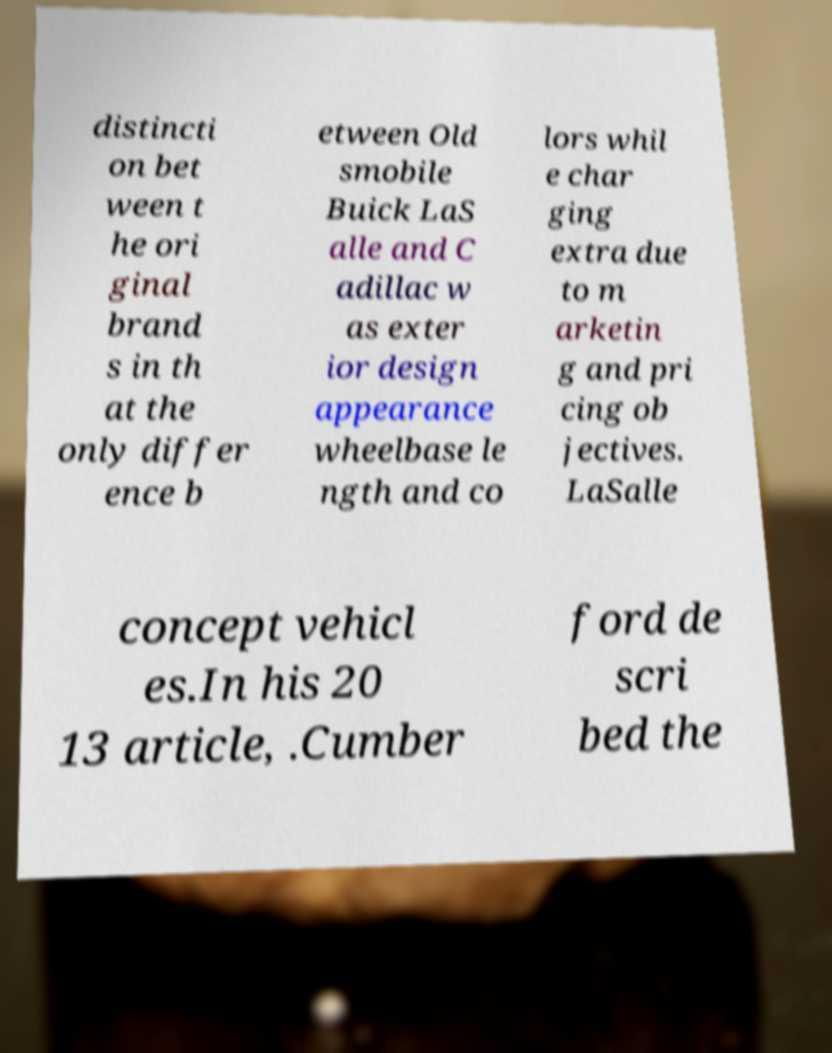Could you assist in decoding the text presented in this image and type it out clearly? distincti on bet ween t he ori ginal brand s in th at the only differ ence b etween Old smobile Buick LaS alle and C adillac w as exter ior design appearance wheelbase le ngth and co lors whil e char ging extra due to m arketin g and pri cing ob jectives. LaSalle concept vehicl es.In his 20 13 article, .Cumber ford de scri bed the 